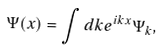<formula> <loc_0><loc_0><loc_500><loc_500>\Psi ( x ) = \int d k e ^ { i k x } \Psi _ { k } ,</formula> 